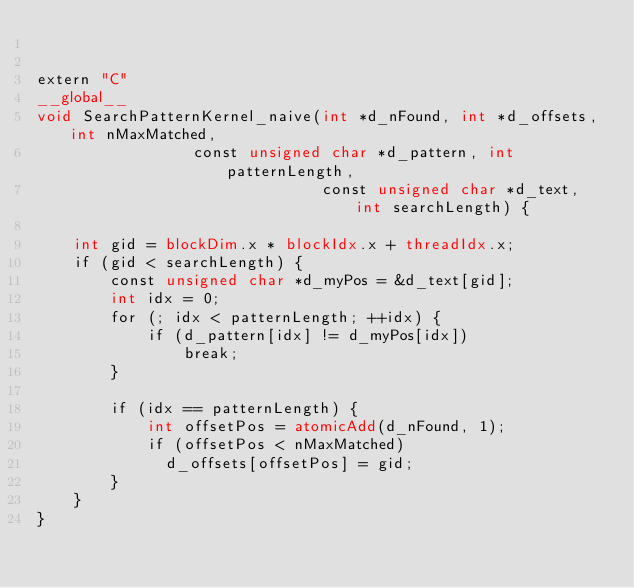<code> <loc_0><loc_0><loc_500><loc_500><_Cuda_>

extern "C"
__global__
void SearchPatternKernel_naive(int *d_nFound, int *d_offsets, int nMaxMatched,
							   const unsigned char *d_pattern, int patternLength,
                               const unsigned char *d_text, int searchLength) {

    int gid = blockDim.x * blockIdx.x + threadIdx.x;
    if (gid < searchLength) {
        const unsigned char *d_myPos = &d_text[gid];
        int idx = 0;
        for (; idx < patternLength; ++idx) {
            if (d_pattern[idx] != d_myPos[idx])
                break;
        }

        if (idx == patternLength) {
            int offsetPos = atomicAdd(d_nFound, 1);
            if (offsetPos < nMaxMatched)
            	d_offsets[offsetPos] = gid;
        }
    }
}
</code> 